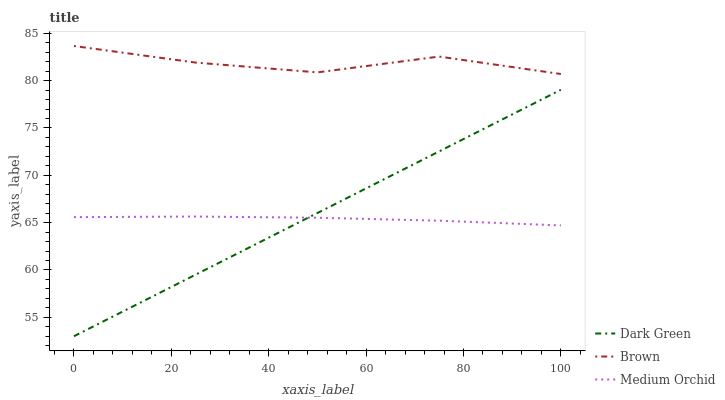Does Medium Orchid have the minimum area under the curve?
Answer yes or no. Yes. Does Brown have the maximum area under the curve?
Answer yes or no. Yes. Does Dark Green have the minimum area under the curve?
Answer yes or no. No. Does Dark Green have the maximum area under the curve?
Answer yes or no. No. Is Dark Green the smoothest?
Answer yes or no. Yes. Is Brown the roughest?
Answer yes or no. Yes. Is Medium Orchid the smoothest?
Answer yes or no. No. Is Medium Orchid the roughest?
Answer yes or no. No. Does Medium Orchid have the lowest value?
Answer yes or no. No. Does Brown have the highest value?
Answer yes or no. Yes. Does Dark Green have the highest value?
Answer yes or no. No. Is Medium Orchid less than Brown?
Answer yes or no. Yes. Is Brown greater than Dark Green?
Answer yes or no. Yes. Does Medium Orchid intersect Dark Green?
Answer yes or no. Yes. Is Medium Orchid less than Dark Green?
Answer yes or no. No. Is Medium Orchid greater than Dark Green?
Answer yes or no. No. Does Medium Orchid intersect Brown?
Answer yes or no. No. 